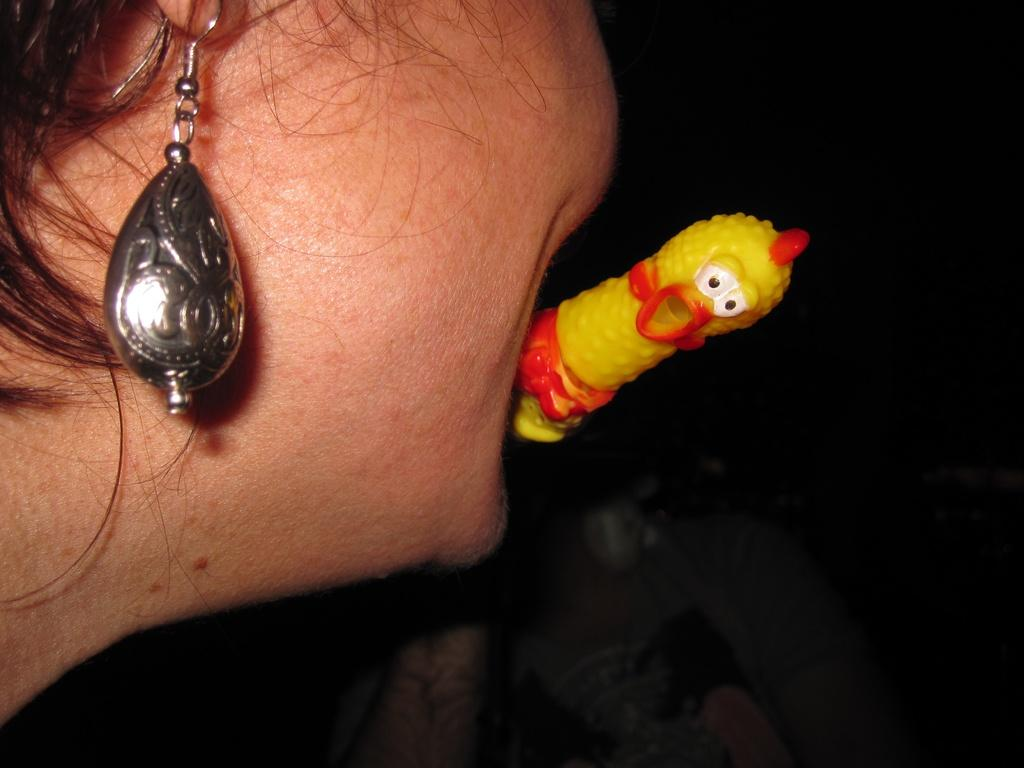What is happening in the image involving a person? The person in the image is catching a toy with their mouth. Can you describe any accessories the person is wearing? There is an earring present in the image. What type of class is being taught in the image? There is no class or teaching activity present in the image. 